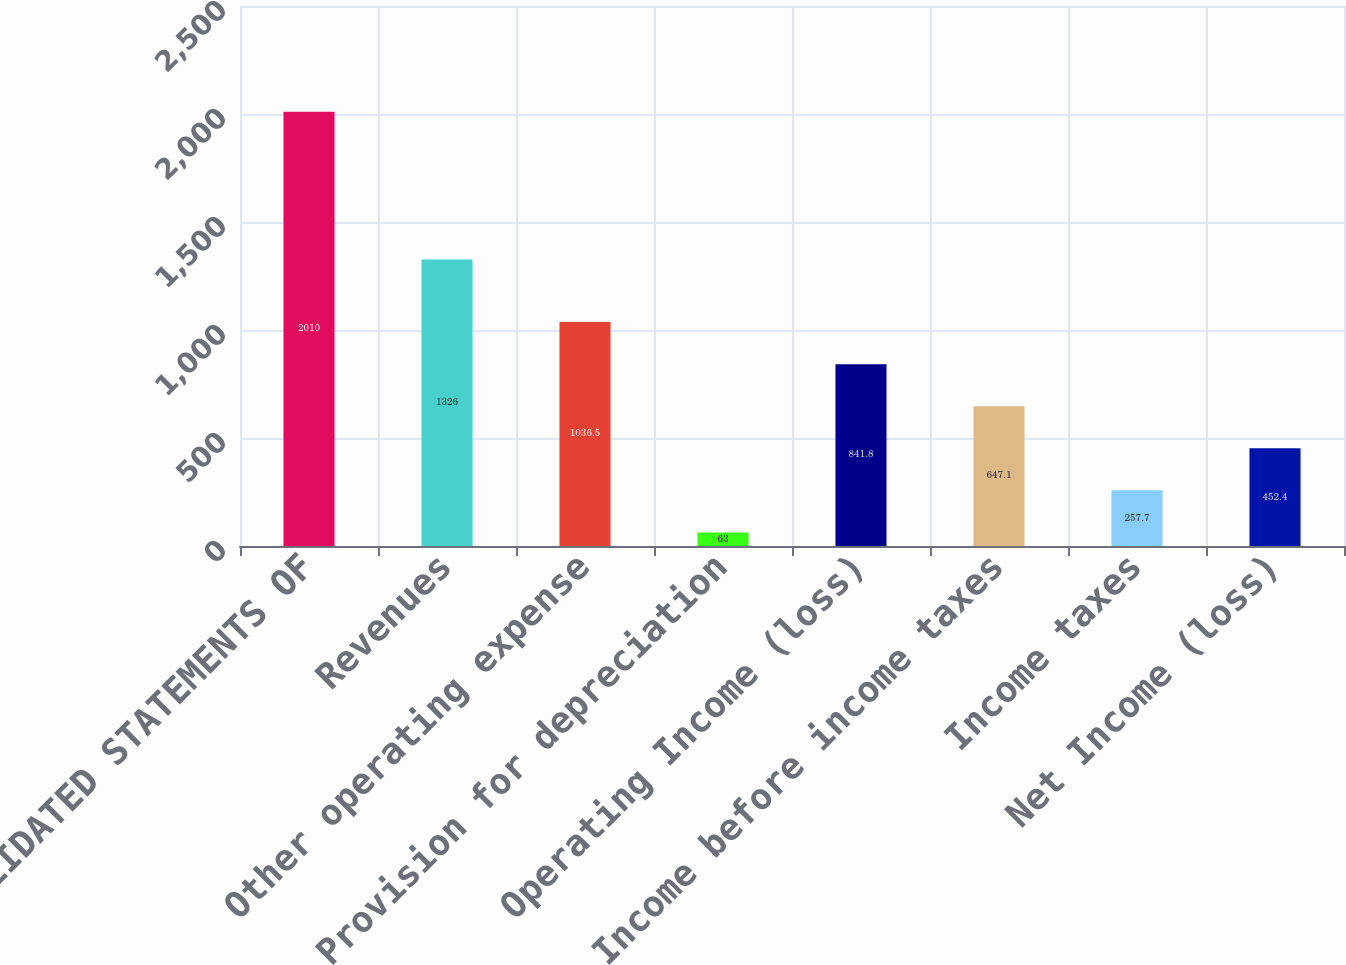<chart> <loc_0><loc_0><loc_500><loc_500><bar_chart><fcel>CONSOLIDATED STATEMENTS OF<fcel>Revenues<fcel>Other operating expense<fcel>Provision for depreciation<fcel>Operating Income (loss)<fcel>Income before income taxes<fcel>Income taxes<fcel>Net Income (loss)<nl><fcel>2010<fcel>1326<fcel>1036.5<fcel>63<fcel>841.8<fcel>647.1<fcel>257.7<fcel>452.4<nl></chart> 